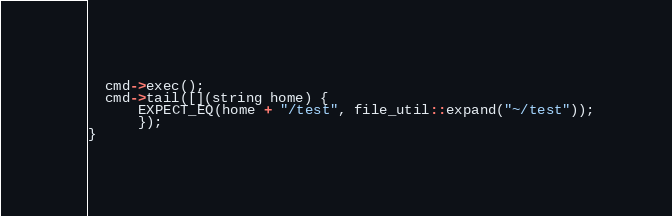<code> <loc_0><loc_0><loc_500><loc_500><_C++_>  cmd->exec();
  cmd->tail([](string home) {
      EXPECT_EQ(home + "/test", file_util::expand("~/test"));
      });
}
</code> 